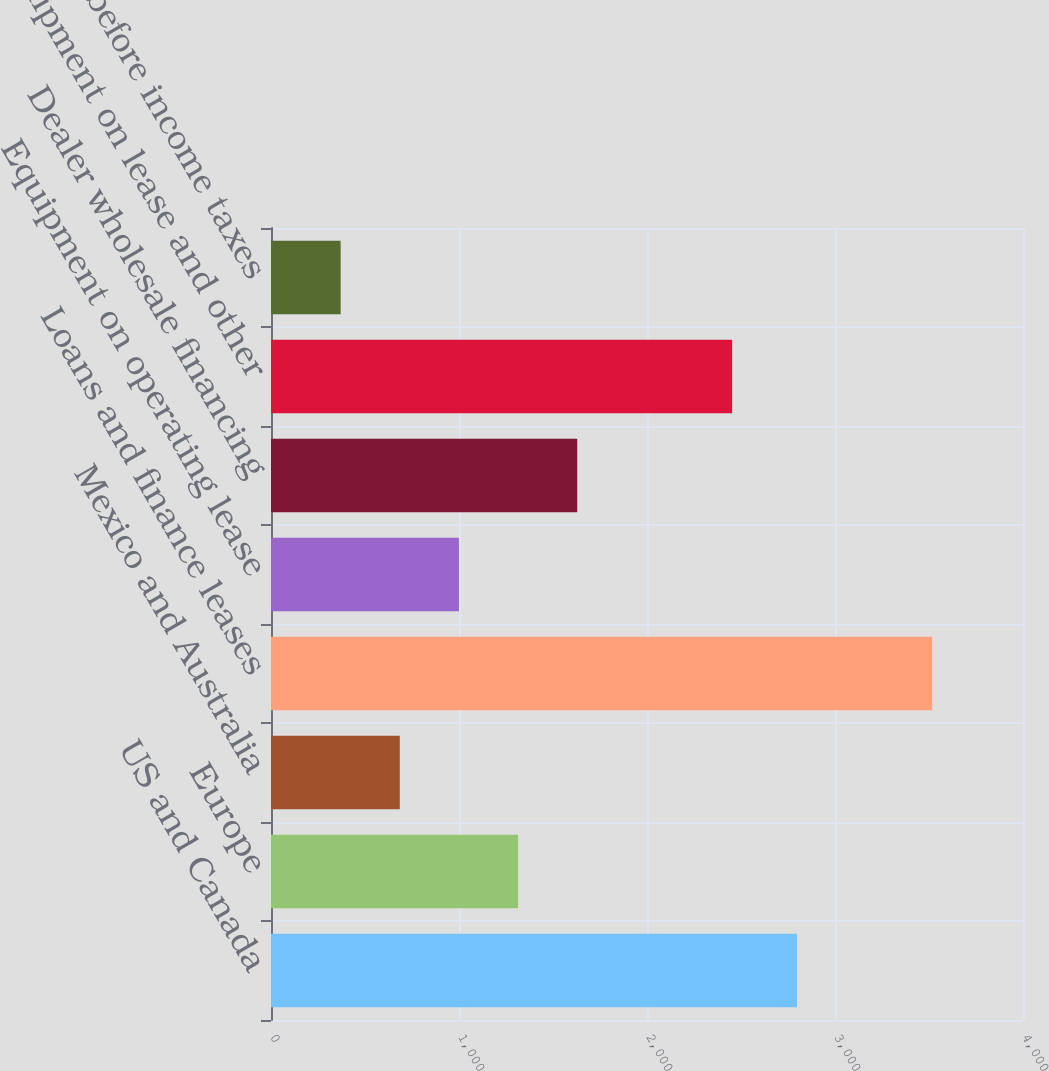Convert chart. <chart><loc_0><loc_0><loc_500><loc_500><bar_chart><fcel>US and Canada<fcel>Europe<fcel>Mexico and Australia<fcel>Loans and finance leases<fcel>Equipment on operating lease<fcel>Dealer wholesale financing<fcel>Equipment on lease and other<fcel>Income before income taxes<nl><fcel>2798.3<fcel>1314.29<fcel>685.03<fcel>3516.7<fcel>999.66<fcel>1628.92<fcel>2452.9<fcel>370.4<nl></chart> 